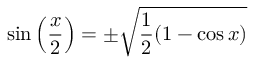<formula> <loc_0><loc_0><loc_500><loc_500>\sin \left ( { \frac { x } { 2 } } \right ) = \pm { \sqrt { { \frac { 1 } { 2 } } ( 1 - \cos x ) } }</formula> 